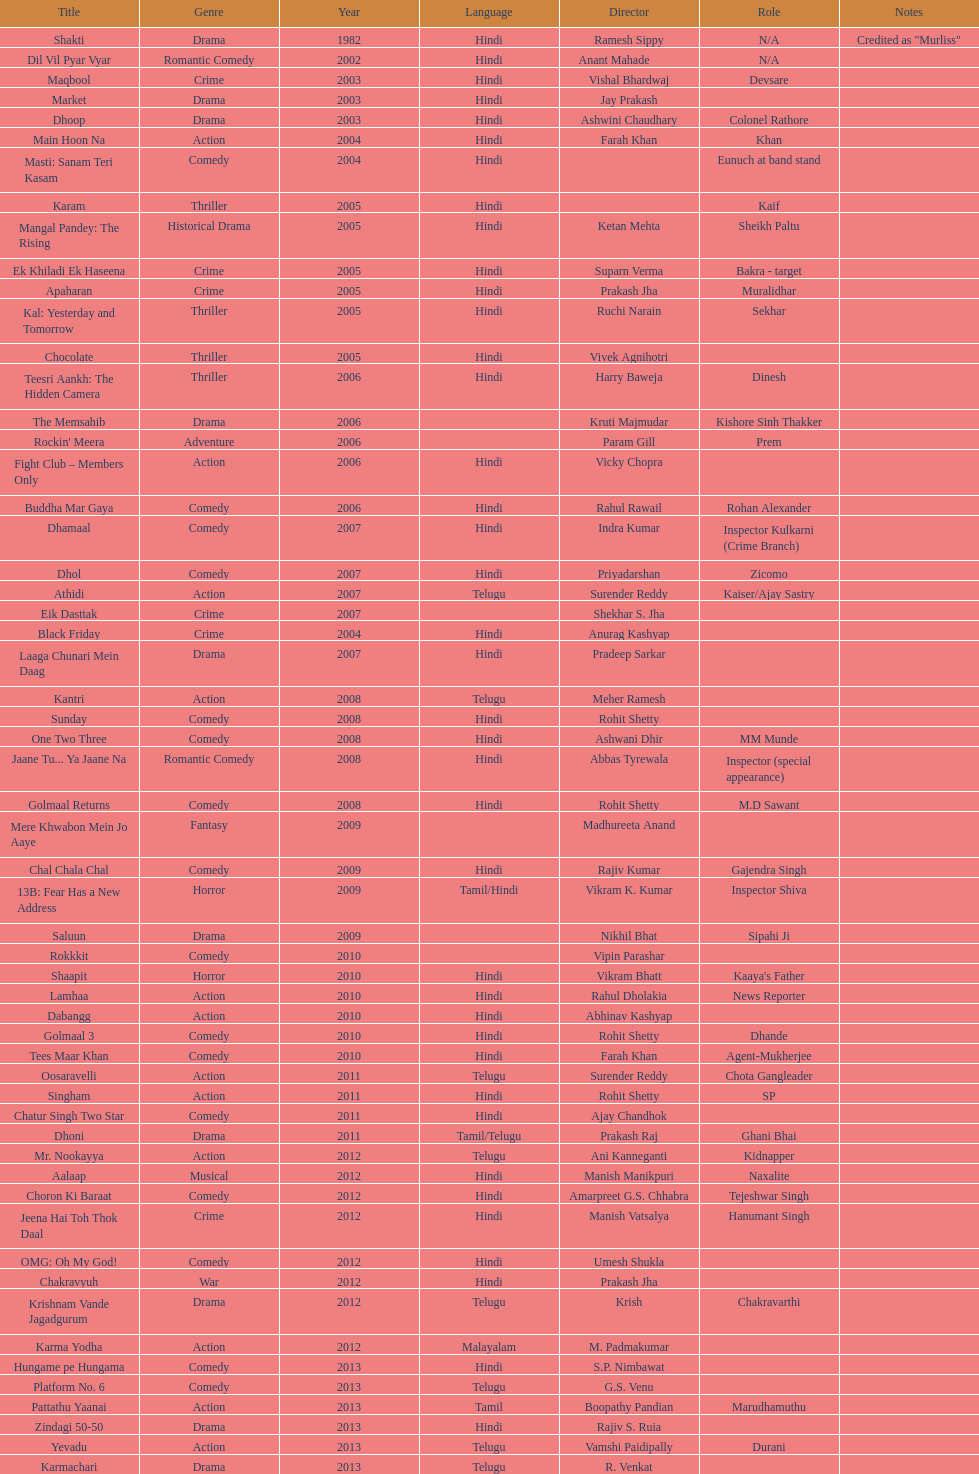What are the number of titles listed in 2005? 6. 